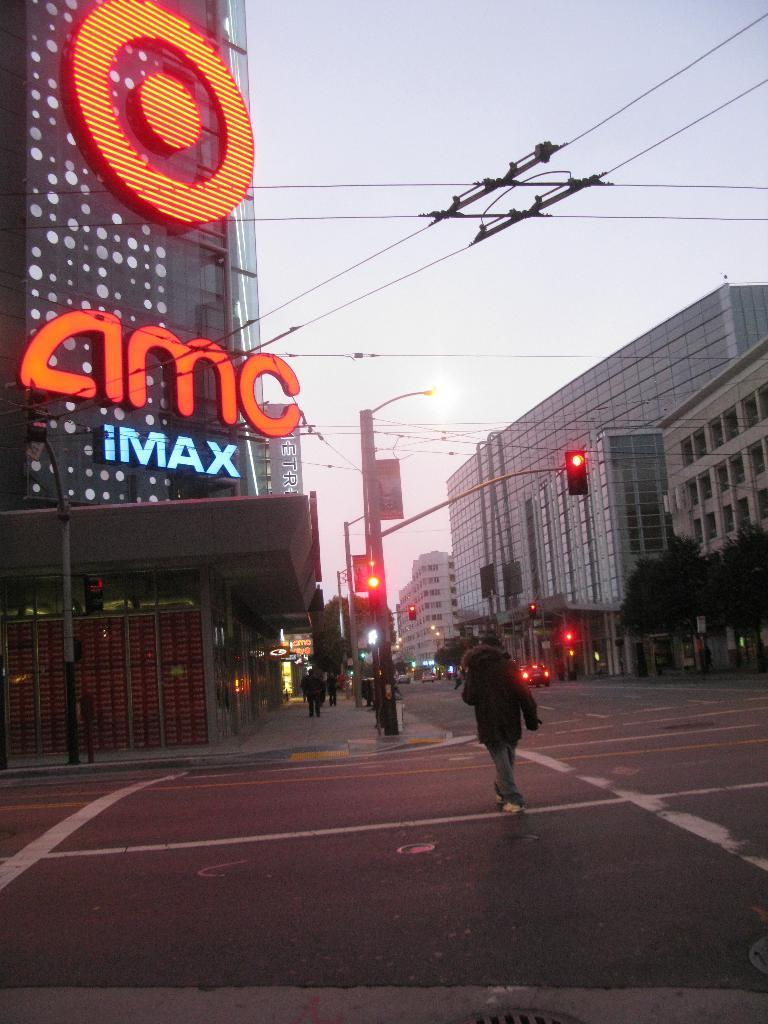<image>
Create a compact narrative representing the image presented. The large cinema pictured is an IMAX cinema. 